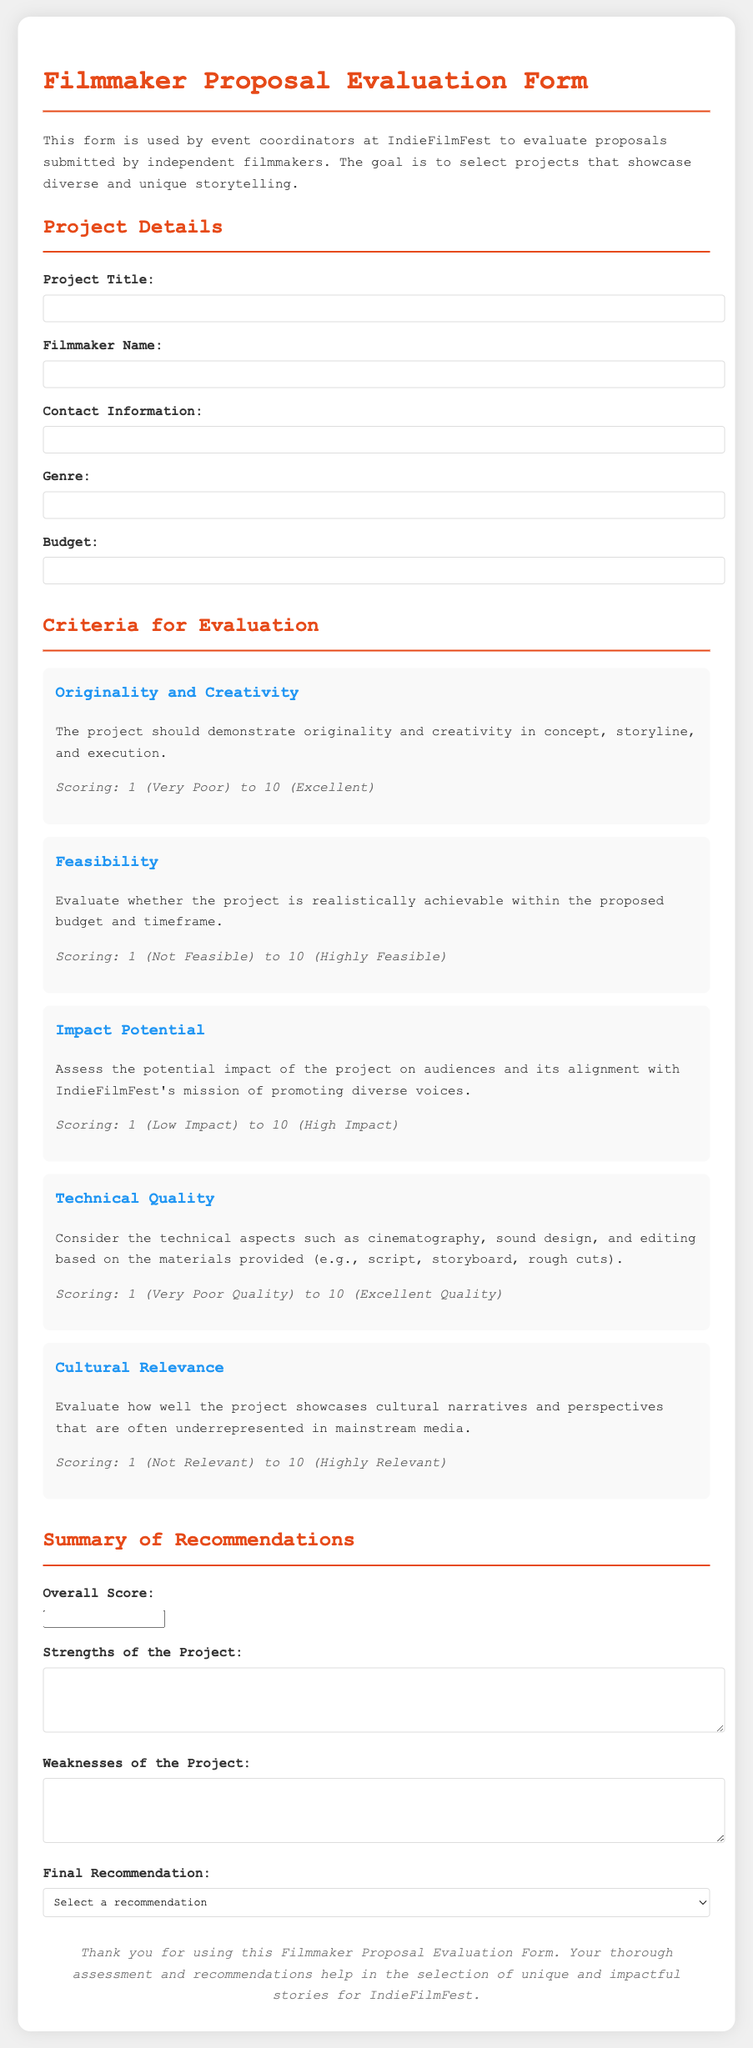what is the title of the document? The document title is the heading of the page which specifies its purpose.
Answer: Filmmaker Proposal Evaluation Form who should use this form? The document describes the intended users, specifically those who handle filmmaker proposals.
Answer: event coordinators what is the maximum score for Originality and Creativity? The scoring system indicates the range for each criterion, with 10 being the highest score.
Answer: 10 what criteria assesses potential impact? The name of the criterion that evaluates audience impact is highlighted in the document.
Answer: Impact Potential which aspect is evaluated under Technical Quality? It refers to the specific technical components that are analyzed in the evaluation process.
Answer: cinematography, sound design, and editing what is the scoring system range for Cultural Relevance? The scoring system is outlined for each criterion, providing the range of scores.
Answer: 1 to 10 how are weaknesses of the project documented? The document specifies how evaluators should articulate the weaknesses they perceive in submissions.
Answer: textarea what is the recommendation option that implies doubt? This selection conveys uncertainty regarding the project's suitability for the festival.
Answer: Recommend with Reservations what is included in the summary of recommendations? The document lists specific elements that should be part of the final evaluation summary.
Answer: Overall Score, Strengths of the Project, Weaknesses of the Project, Final Recommendation 